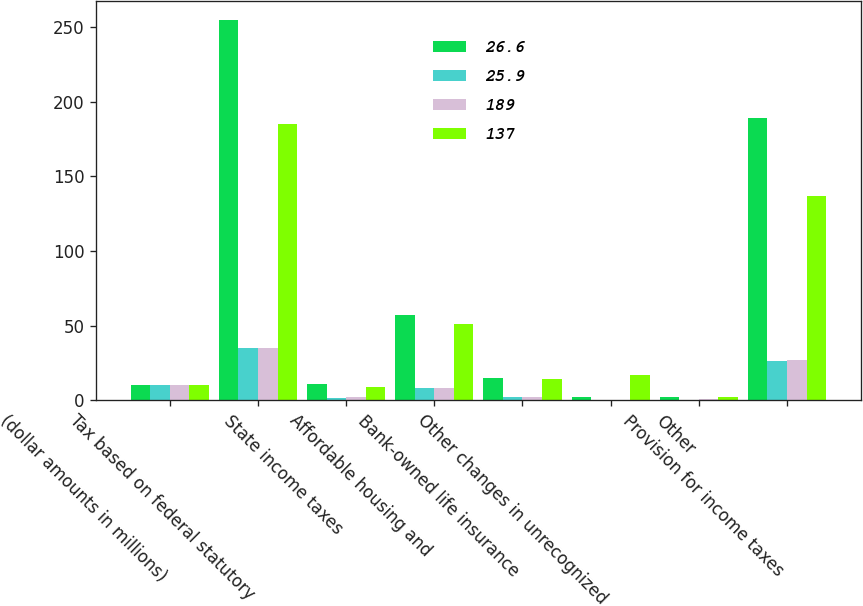Convert chart to OTSL. <chart><loc_0><loc_0><loc_500><loc_500><stacked_bar_chart><ecel><fcel>(dollar amounts in millions)<fcel>Tax based on federal statutory<fcel>State income taxes<fcel>Affordable housing and<fcel>Bank-owned life insurance<fcel>Other changes in unrecognized<fcel>Other<fcel>Provision for income taxes<nl><fcel>26.6<fcel>10<fcel>255<fcel>11<fcel>57<fcel>15<fcel>2<fcel>2<fcel>189<nl><fcel>25.9<fcel>10<fcel>35<fcel>1.5<fcel>7.8<fcel>2.1<fcel>0.2<fcel>0.4<fcel>25.9<nl><fcel>189<fcel>10<fcel>35<fcel>2<fcel>7.8<fcel>2.1<fcel>0.2<fcel>0.7<fcel>26.6<nl><fcel>137<fcel>10<fcel>185<fcel>9<fcel>51<fcel>14<fcel>17<fcel>2<fcel>137<nl></chart> 